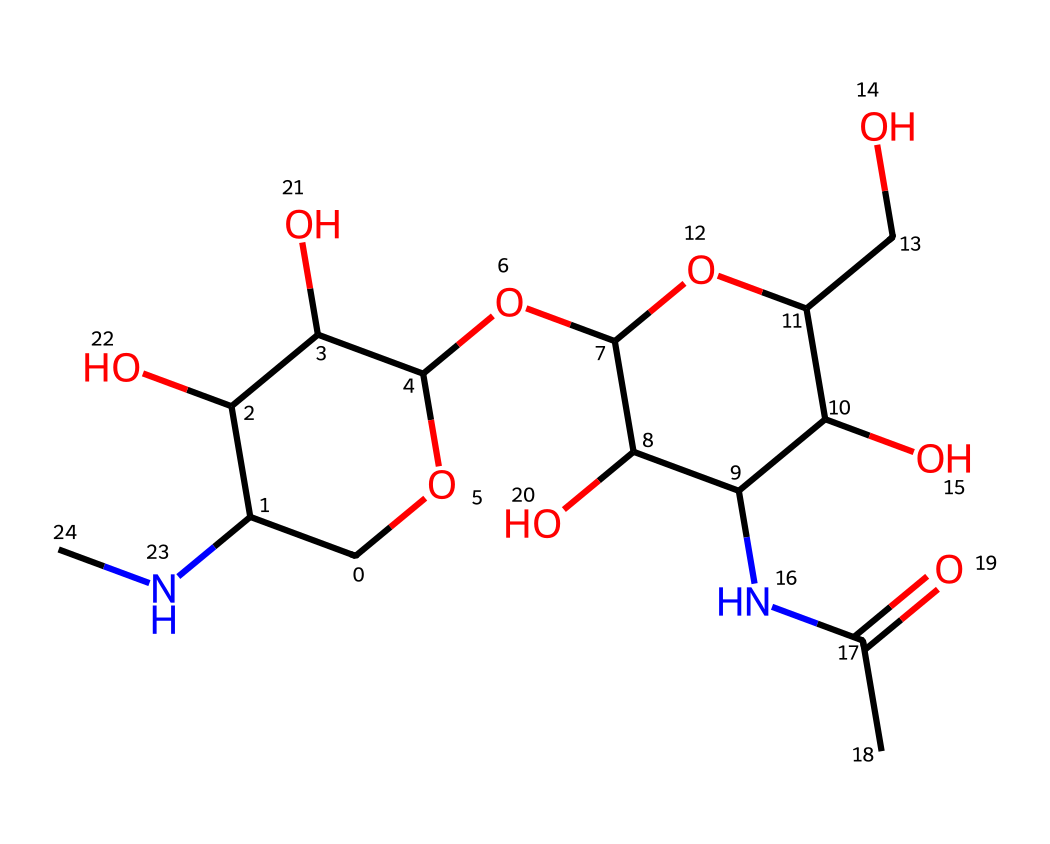What is the molecular formula of chitosan? To determine the molecular formula, we count the number of each type of atom in the provided SMILES representation. The structure contains multiple carbons (C), hydrogens (H), nitrogens (N), and oxygens (O). After counting, we find that the molecular formula is C8H13N1O6.
Answer: C8H13N1O6 How many nitrogen atoms are present in chitosan? By analyzing the provided SMILES, we look for "N" which represents nitrogen. There is one nitrogen atom visible in the structure representation.
Answer: 1 What type of polymer is chitosan classified as? Chitosan is classified as a biodegradable polymer due to its natural origin (derived from chitin) and its ability to break down under environmental conditions.
Answer: biodegradable How many hydroxyl (–OH) groups are present in the structure? To answer this, we identify the –OH groups in the structure, which appear as parts connected to carbon atoms. On inspecting the SMILES, we find four –OH groups attached to the carbon skeleton.
Answer: 4 What functional group is associated with the nitrogen in chitosan? The nitrogen in the structure is part of an amine functional group, which can be identified by the presence of a nitrogen atom connected to carbon and hydrogen or another group. Here, it is seen in the context of a secondary amine.
Answer: amine Does chitosan have any repeating units of monomers? Analyzing the structure, chitosan is made from repeating units of glucosamine, which is evident from its structure containing multiple similar groups. Therefore, it does have repeating units.
Answer: yes What is the significance of the acetyl group in chitosan? The acetyl group, represented by –C(=O)NH in the structure, is significant because it influences the solubility and the biological properties of chitosan, enhancing its functionality in applications like wildlife tracking devices.
Answer: solubility 